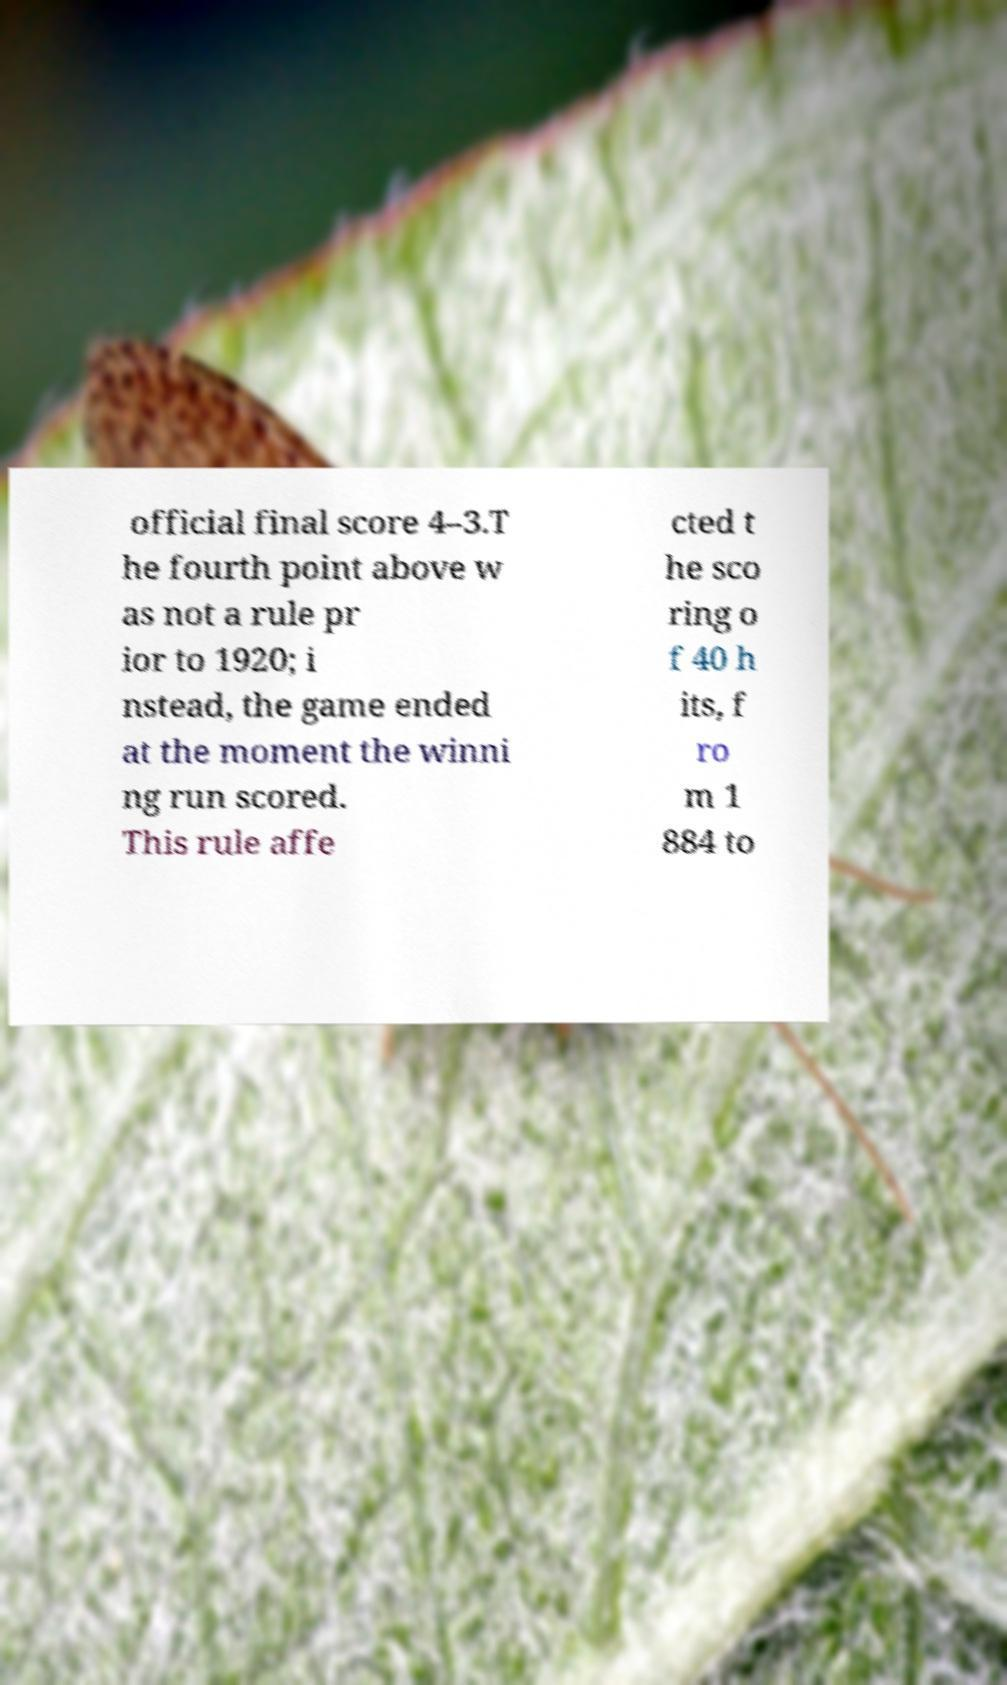There's text embedded in this image that I need extracted. Can you transcribe it verbatim? official final score 4–3.T he fourth point above w as not a rule pr ior to 1920; i nstead, the game ended at the moment the winni ng run scored. This rule affe cted t he sco ring o f 40 h its, f ro m 1 884 to 